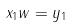<formula> <loc_0><loc_0><loc_500><loc_500>x _ { 1 } w = y _ { 1 }</formula> 